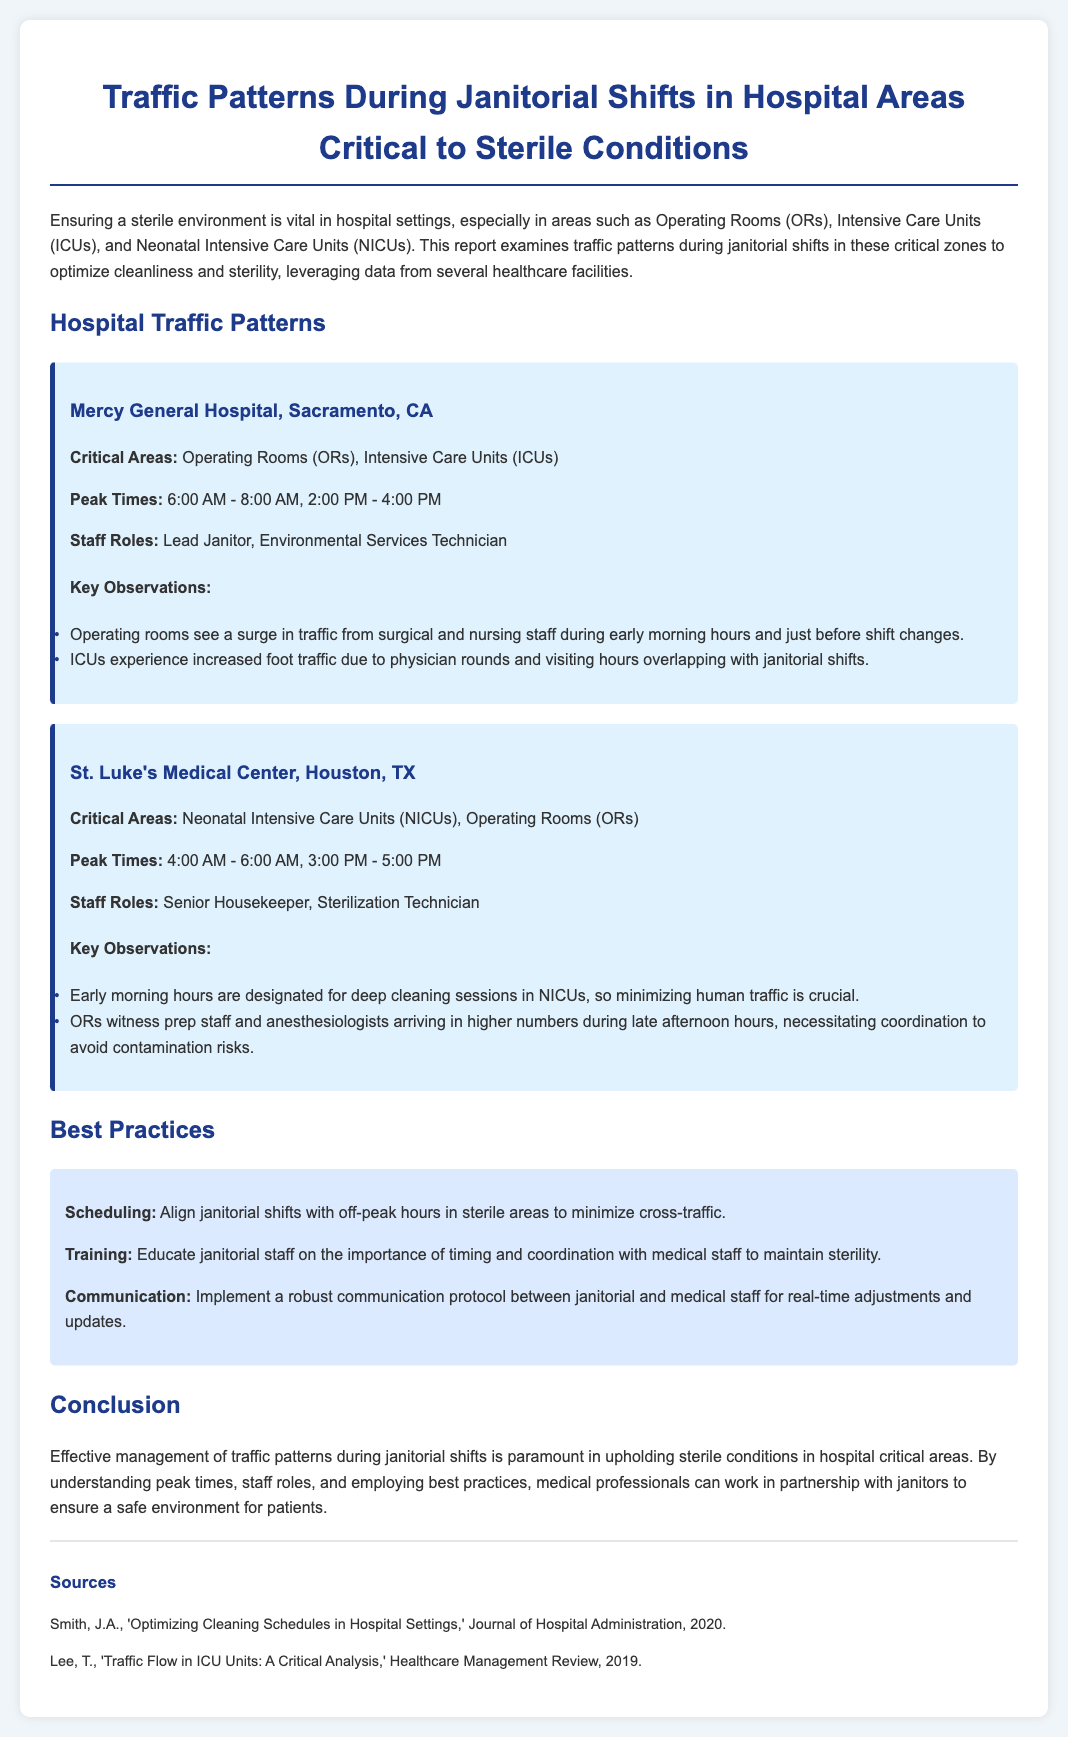what are the peak times at Mercy General Hospital? Peak times are the periods of highest traffic as indicated in the report, which are from 6:00 AM - 8:00 AM and 2:00 PM - 4:00 PM.
Answer: 6:00 AM - 8:00 AM, 2:00 PM - 4:00 PM which areas are considered critical at St. Luke's Medical Center? The report states that the critical areas at St. Luke's Medical Center are where a sterile environment is necessary, specifically the Neonatal Intensive Care Units (NICUs) and Operating Rooms (ORs).
Answer: NICUs, Operating Rooms what is a key observation regarding traffic in Operating Rooms? The observations highlight specific patterns of foot traffic which peak during notable hours, particularly a surge from surgical and nursing staff during early morning hours and just before shift changes.
Answer: Surge in traffic during early morning hours and just before shift changes what is the recommended practice for scheduling janitorial shifts? The document suggests that aligning janitorial shifts with off-peak hours in sterile areas is essential to minimize cross-traffic and maintain sterility.
Answer: Align shifts with off-peak hours who are the staff roles mentioned at Mercy General Hospital? The staff roles refer to the individuals responsible for maintaining cleanliness and sterility in the critical areas; in this case, it includes the Lead Janitor and Environmental Services Technician.
Answer: Lead Janitor, Environmental Services Technician how does staff communication impact the janitorial operations? The report emphasizes the importance of establishing a communication protocol that enables janitorial and medical staff to coordinate effectively, thus supporting the goal of maintaining a sterile environment.
Answer: Implement a robust communication protocol what are the peak times for janitorial work in NICUs at St. Luke's Medical Center? The document specifies that the peak times for janitorial work in NICUs are crucially in the early morning hours as these periods are designated for deep cleaning.
Answer: 4:00 AM - 6:00 AM what should janitorial staff be educated about according to best practices? The document emphasizes the need for training janitorial staff regarding the significance of timing and coordination with medical staff to ensure the maintenance of sterility in hospital environments.
Answer: Importance of timing and coordination 